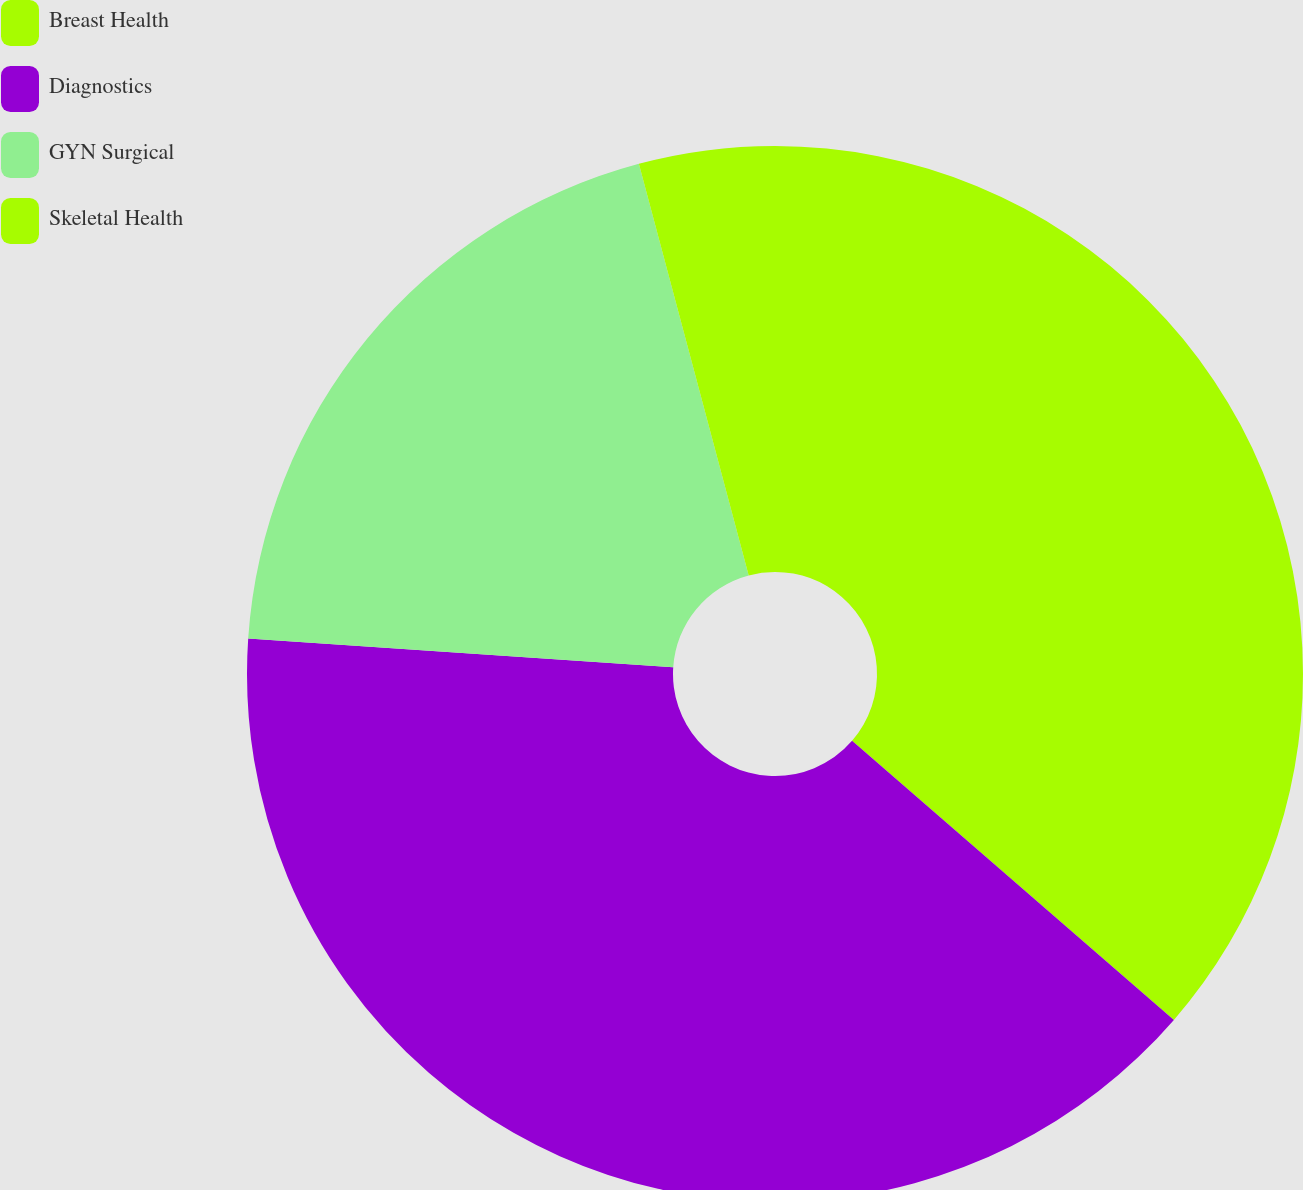Convert chart to OTSL. <chart><loc_0><loc_0><loc_500><loc_500><pie_chart><fcel>Breast Health<fcel>Diagnostics<fcel>GYN Surgical<fcel>Skeletal Health<nl><fcel>36.37%<fcel>39.7%<fcel>19.78%<fcel>4.15%<nl></chart> 